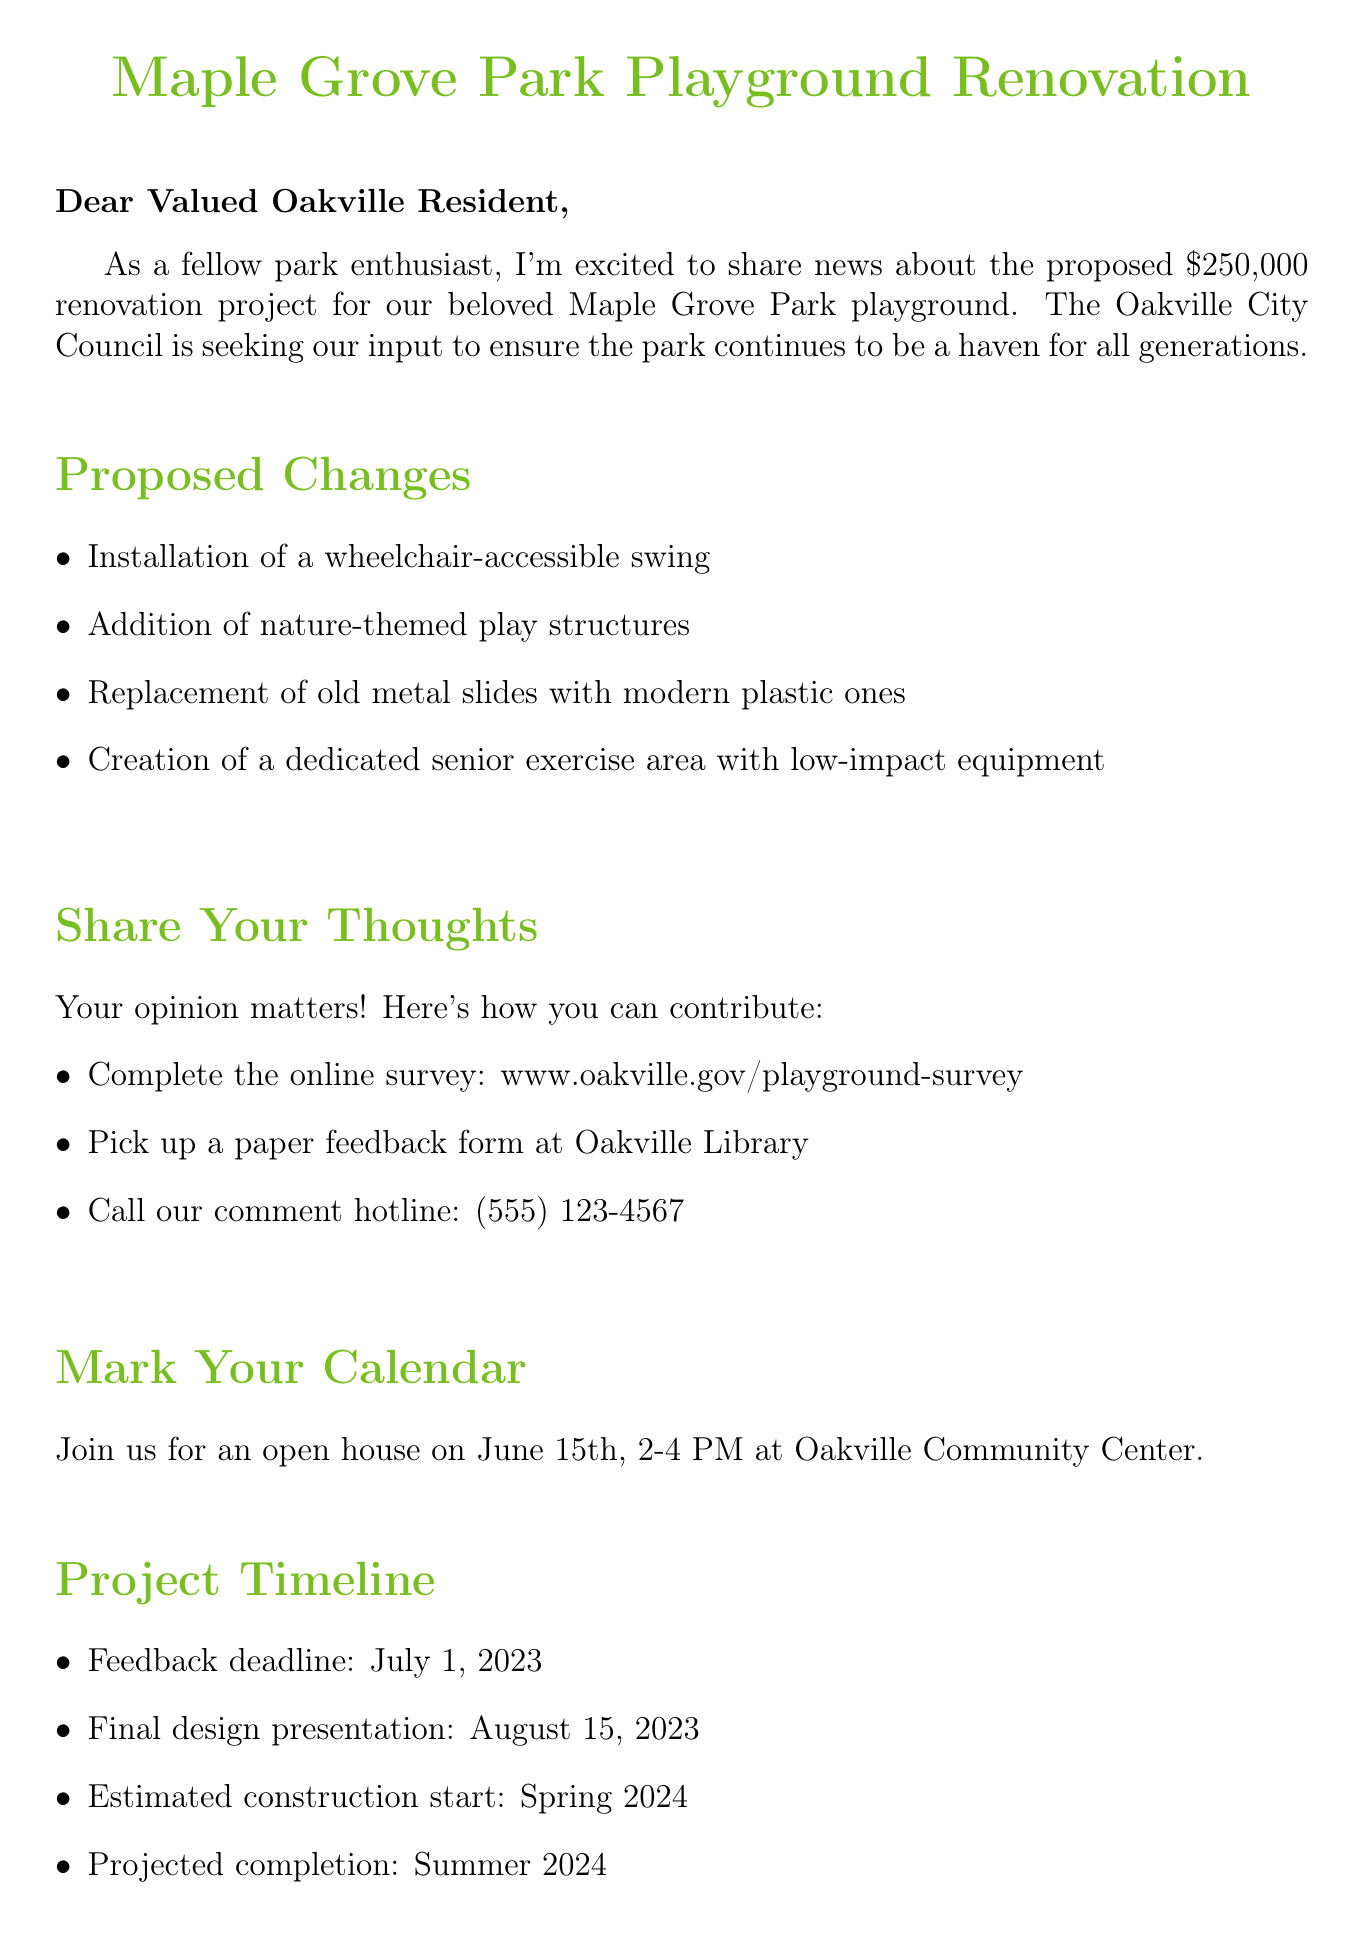What is the proposed budget for the renovation? The proposed budget for the renovation project is stated clearly in the document as $250,000.
Answer: $250,000 What new feature will be added for accessibility? The document explicitly mentions the installation of a wheelchair-accessible swing as a new feature for accessibility.
Answer: Wheelchair-accessible swing When is the open house scheduled? The date and time for the open house is provided in the document, which indicates it is on June 15th, from 2-4 PM.
Answer: June 15th, 2-4 PM Who is the contact person for the project? The document includes the name of the contact person responsible for the project, which is Sarah Thompson.
Answer: Sarah Thompson What is the feedback deadline? The document lists the feedback deadline, which is July 1, 2023, as part of the project timeline.
Answer: July 1, 2023 Which group is specifically mentioned to benefit from the renovations? The document indicates that the renovation project aims to benefit all age groups, specifically mentioning seniors with grandchildren.
Answer: Seniors with grandchildren What method is NOT mentioned for giving feedback? Upon reviewing the feedback options, it is clear that postal mail is not mentioned as a method for providing feedback.
Answer: Postal mail What is the expected completion season of the project? The document states that the projected completion for the renovation project is in the summer of 2024.
Answer: Summer 2024 